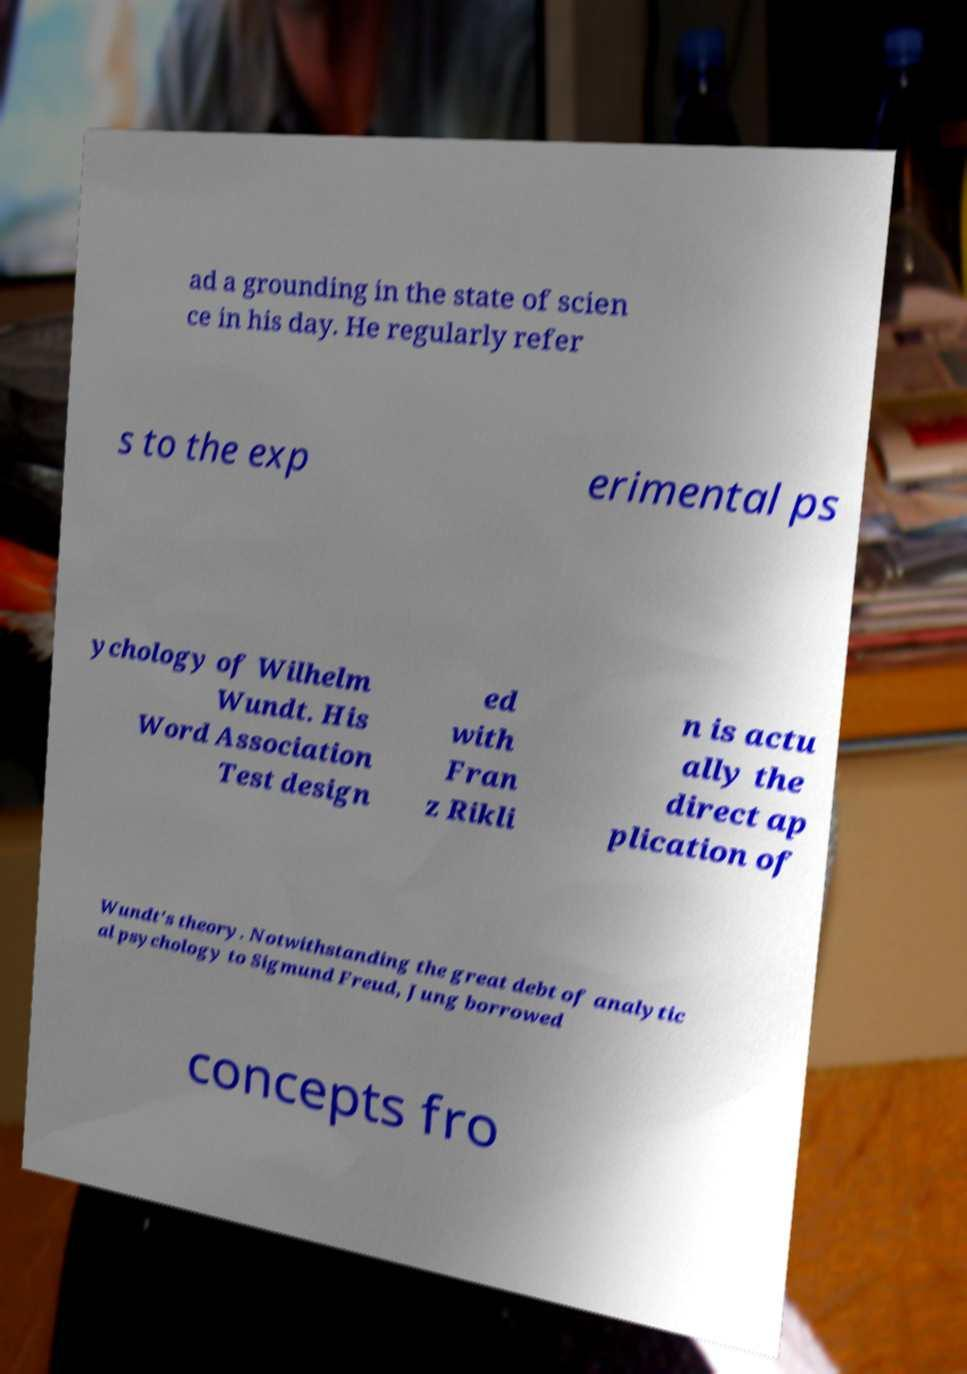Can you read and provide the text displayed in the image?This photo seems to have some interesting text. Can you extract and type it out for me? ad a grounding in the state of scien ce in his day. He regularly refer s to the exp erimental ps ychology of Wilhelm Wundt. His Word Association Test design ed with Fran z Rikli n is actu ally the direct ap plication of Wundt's theory. Notwithstanding the great debt of analytic al psychology to Sigmund Freud, Jung borrowed concepts fro 